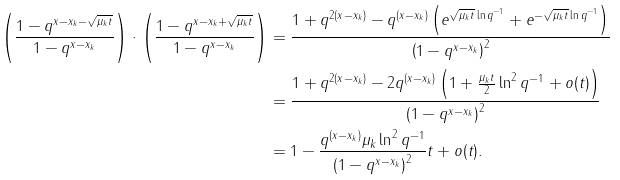Convert formula to latex. <formula><loc_0><loc_0><loc_500><loc_500>\left ( \frac { 1 - q ^ { x - x _ { k } - \sqrt { \mu _ { k } t } } } { 1 - q ^ { x - x _ { k } } } \right ) \cdot \left ( \frac { 1 - q ^ { x - x _ { k } + \sqrt { \mu _ { k } t } } } { 1 - q ^ { x - x _ { k } } } \right ) & = \frac { 1 + q ^ { 2 ( x - x _ { k } ) } - q ^ { ( x - x _ { k } ) } \left ( e ^ { \sqrt { \mu _ { k } t } \ln q ^ { - 1 } } + e ^ { - \sqrt { \mu _ { k } t } \ln q ^ { - 1 } } \right ) } { \left ( 1 - q ^ { x - x _ { k } } \right ) ^ { 2 } } \\ & = \frac { 1 + q ^ { 2 ( x - x _ { k } ) } - 2 q ^ { ( x - x _ { k } ) } \left ( 1 + \frac { \mu _ { k } t } { 2 } \ln ^ { 2 } q ^ { - 1 } + o ( t ) \right ) } { \left ( 1 - q ^ { x - x _ { k } } \right ) ^ { 2 } } \\ & = 1 - \frac { q ^ { ( x - x _ { k } ) } \mu _ { k } \ln ^ { 2 } q ^ { - 1 } } { \left ( 1 - q ^ { x - x _ { k } } \right ) ^ { 2 } } t + o ( t ) .</formula> 